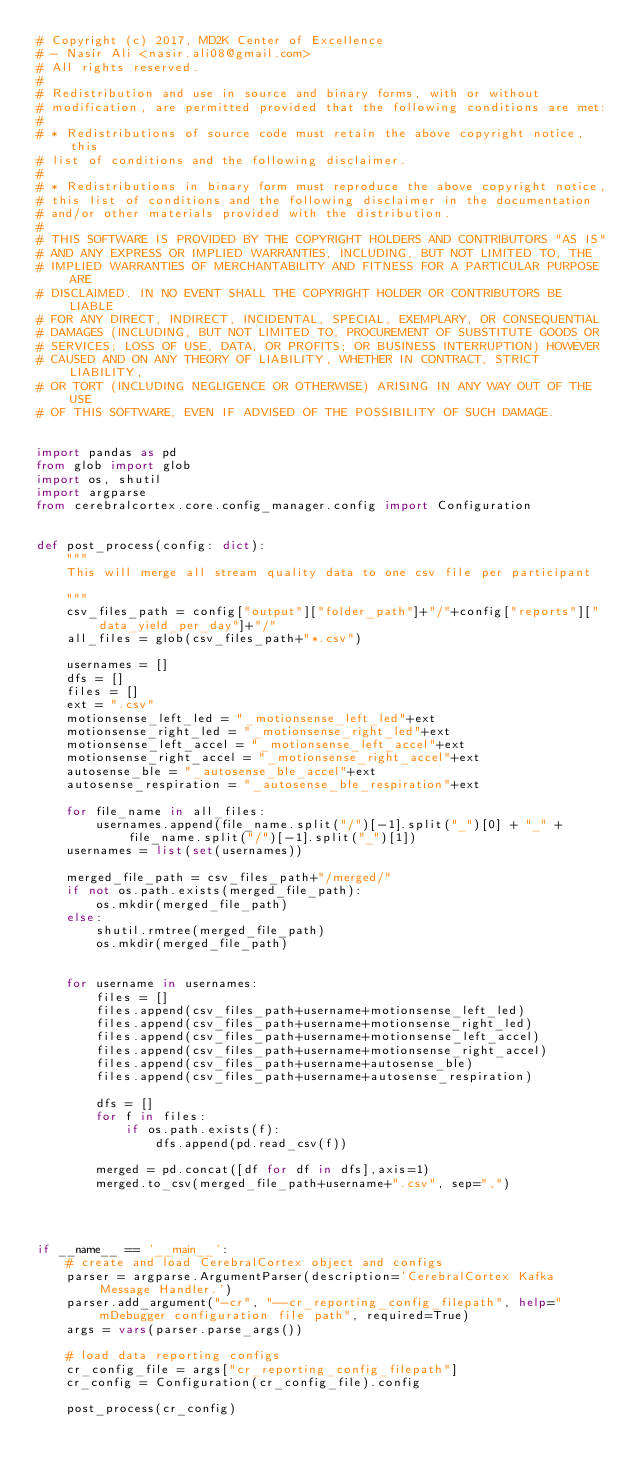Convert code to text. <code><loc_0><loc_0><loc_500><loc_500><_Python_># Copyright (c) 2017, MD2K Center of Excellence
# - Nasir Ali <nasir.ali08@gmail.com>
# All rights reserved.
#
# Redistribution and use in source and binary forms, with or without
# modification, are permitted provided that the following conditions are met:
#
# * Redistributions of source code must retain the above copyright notice, this
# list of conditions and the following disclaimer.
#
# * Redistributions in binary form must reproduce the above copyright notice,
# this list of conditions and the following disclaimer in the documentation
# and/or other materials provided with the distribution.
#
# THIS SOFTWARE IS PROVIDED BY THE COPYRIGHT HOLDERS AND CONTRIBUTORS "AS IS"
# AND ANY EXPRESS OR IMPLIED WARRANTIES, INCLUDING, BUT NOT LIMITED TO, THE
# IMPLIED WARRANTIES OF MERCHANTABILITY AND FITNESS FOR A PARTICULAR PURPOSE ARE
# DISCLAIMED. IN NO EVENT SHALL THE COPYRIGHT HOLDER OR CONTRIBUTORS BE LIABLE
# FOR ANY DIRECT, INDIRECT, INCIDENTAL, SPECIAL, EXEMPLARY, OR CONSEQUENTIAL
# DAMAGES (INCLUDING, BUT NOT LIMITED TO, PROCUREMENT OF SUBSTITUTE GOODS OR
# SERVICES; LOSS OF USE, DATA, OR PROFITS; OR BUSINESS INTERRUPTION) HOWEVER
# CAUSED AND ON ANY THEORY OF LIABILITY, WHETHER IN CONTRACT, STRICT LIABILITY,
# OR TORT (INCLUDING NEGLIGENCE OR OTHERWISE) ARISING IN ANY WAY OUT OF THE USE
# OF THIS SOFTWARE, EVEN IF ADVISED OF THE POSSIBILITY OF SUCH DAMAGE.


import pandas as pd
from glob import glob
import os, shutil
import argparse
from cerebralcortex.core.config_manager.config import Configuration


def post_process(config: dict):
    """
    This will merge all stream quality data to one csv file per participant

    """
    csv_files_path = config["output"]["folder_path"]+"/"+config["reports"]["data_yield_per_day"]+"/"
    all_files = glob(csv_files_path+"*.csv")

    usernames = []
    dfs = []
    files = []
    ext = ".csv"
    motionsense_left_led = "_motionsense_left_led"+ext
    motionsense_right_led = "_motionsense_right_led"+ext
    motionsense_left_accel = "_motionsense_left_accel"+ext
    motionsense_right_accel = "_motionsense_right_accel"+ext
    autosense_ble = "_autosense_ble_accel"+ext
    autosense_respiration = "_autosense_ble_respiration"+ext

    for file_name in all_files:
        usernames.append(file_name.split("/")[-1].split("_")[0] + "_" + file_name.split("/")[-1].split("_")[1])
    usernames = list(set(usernames))

    merged_file_path = csv_files_path+"/merged/"
    if not os.path.exists(merged_file_path):
        os.mkdir(merged_file_path)
    else:
        shutil.rmtree(merged_file_path)
        os.mkdir(merged_file_path)


    for username in usernames:
        files = []
        files.append(csv_files_path+username+motionsense_left_led)
        files.append(csv_files_path+username+motionsense_right_led)
        files.append(csv_files_path+username+motionsense_left_accel)
        files.append(csv_files_path+username+motionsense_right_accel)
        files.append(csv_files_path+username+autosense_ble)
        files.append(csv_files_path+username+autosense_respiration)

        dfs = []
        for f in files:
            if os.path.exists(f):
                dfs.append(pd.read_csv(f))

        merged = pd.concat([df for df in dfs],axis=1)
        merged.to_csv(merged_file_path+username+".csv", sep=",")




if __name__ == '__main__':
    # create and load CerebralCortex object and configs
    parser = argparse.ArgumentParser(description='CerebralCortex Kafka Message Handler.')
    parser.add_argument("-cr", "--cr_reporting_config_filepath", help="mDebugger configuration file path", required=True)
    args = vars(parser.parse_args())

    # load data reporting configs
    cr_config_file = args["cr_reporting_config_filepath"]
    cr_config = Configuration(cr_config_file).config

    post_process(cr_config)
</code> 